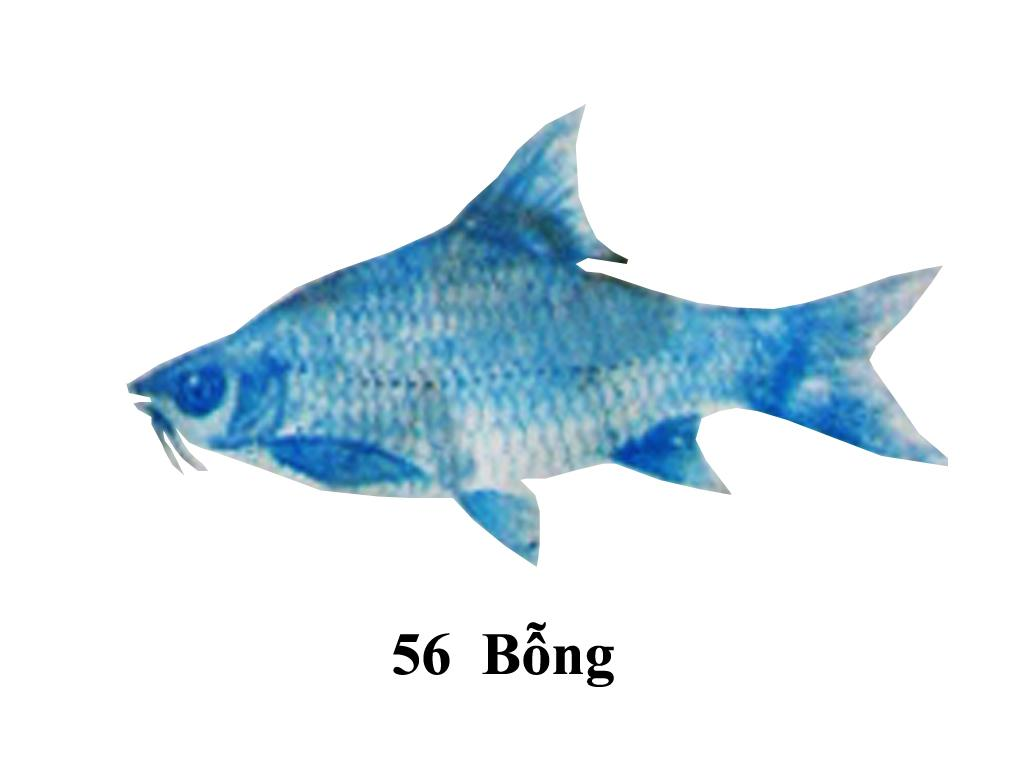What type of animals can be seen in the image? There are blue color fish in the image. What is written or depicted at the bottom of the image? There is text and a number at the bottom of the image. What is the color of the background in the image? The background of the image is white. How many eggs does the maid have on her wrist in the image? There is no maid or eggs present in the image. What type of wrist accessory does the fish have in the image? The fish do not have any wrist accessories in the image. 